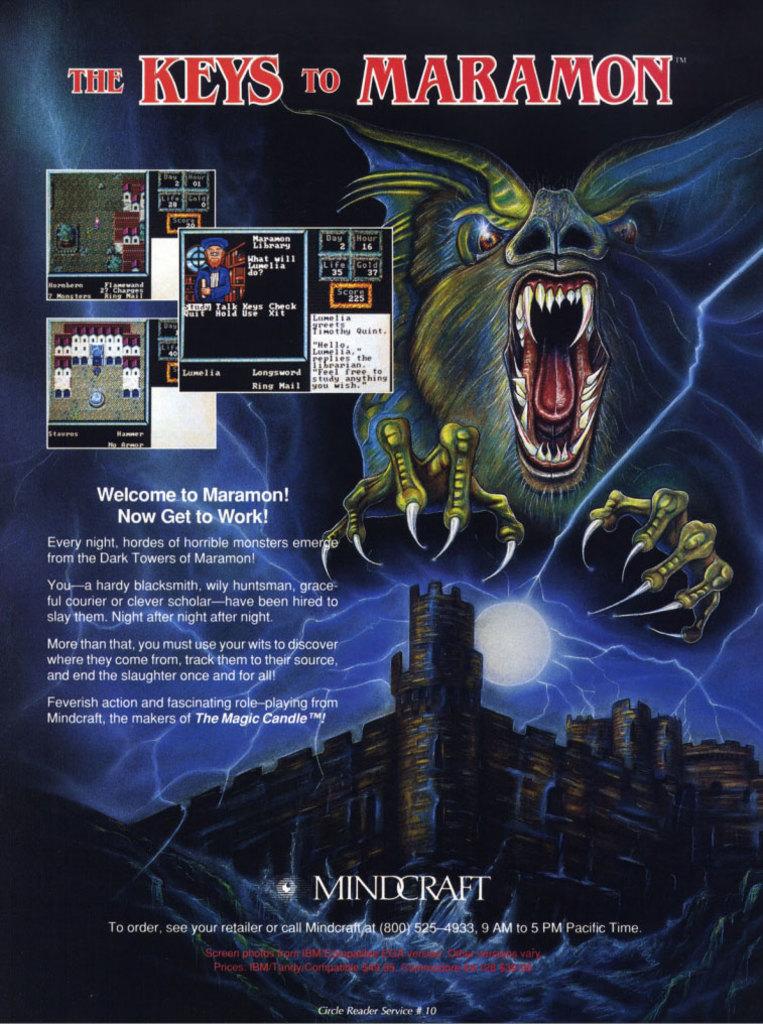What are the words in red right at the top?
Provide a short and direct response. The keys to maramon. What is the phone number for mindcraft?
Keep it short and to the point. 800-525-4933. 